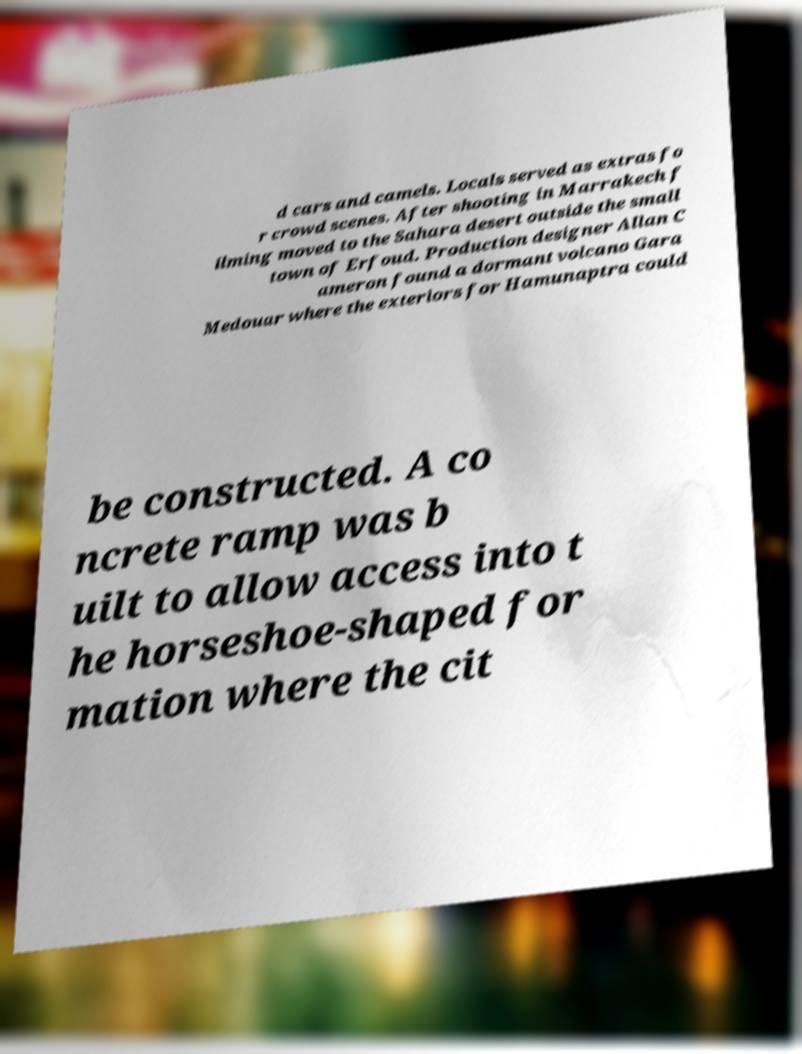Please identify and transcribe the text found in this image. d cars and camels. Locals served as extras fo r crowd scenes. After shooting in Marrakech f ilming moved to the Sahara desert outside the small town of Erfoud. Production designer Allan C ameron found a dormant volcano Gara Medouar where the exteriors for Hamunaptra could be constructed. A co ncrete ramp was b uilt to allow access into t he horseshoe-shaped for mation where the cit 